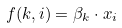Convert formula to latex. <formula><loc_0><loc_0><loc_500><loc_500>f ( k , i ) = \beta _ { k } \cdot x _ { i }</formula> 